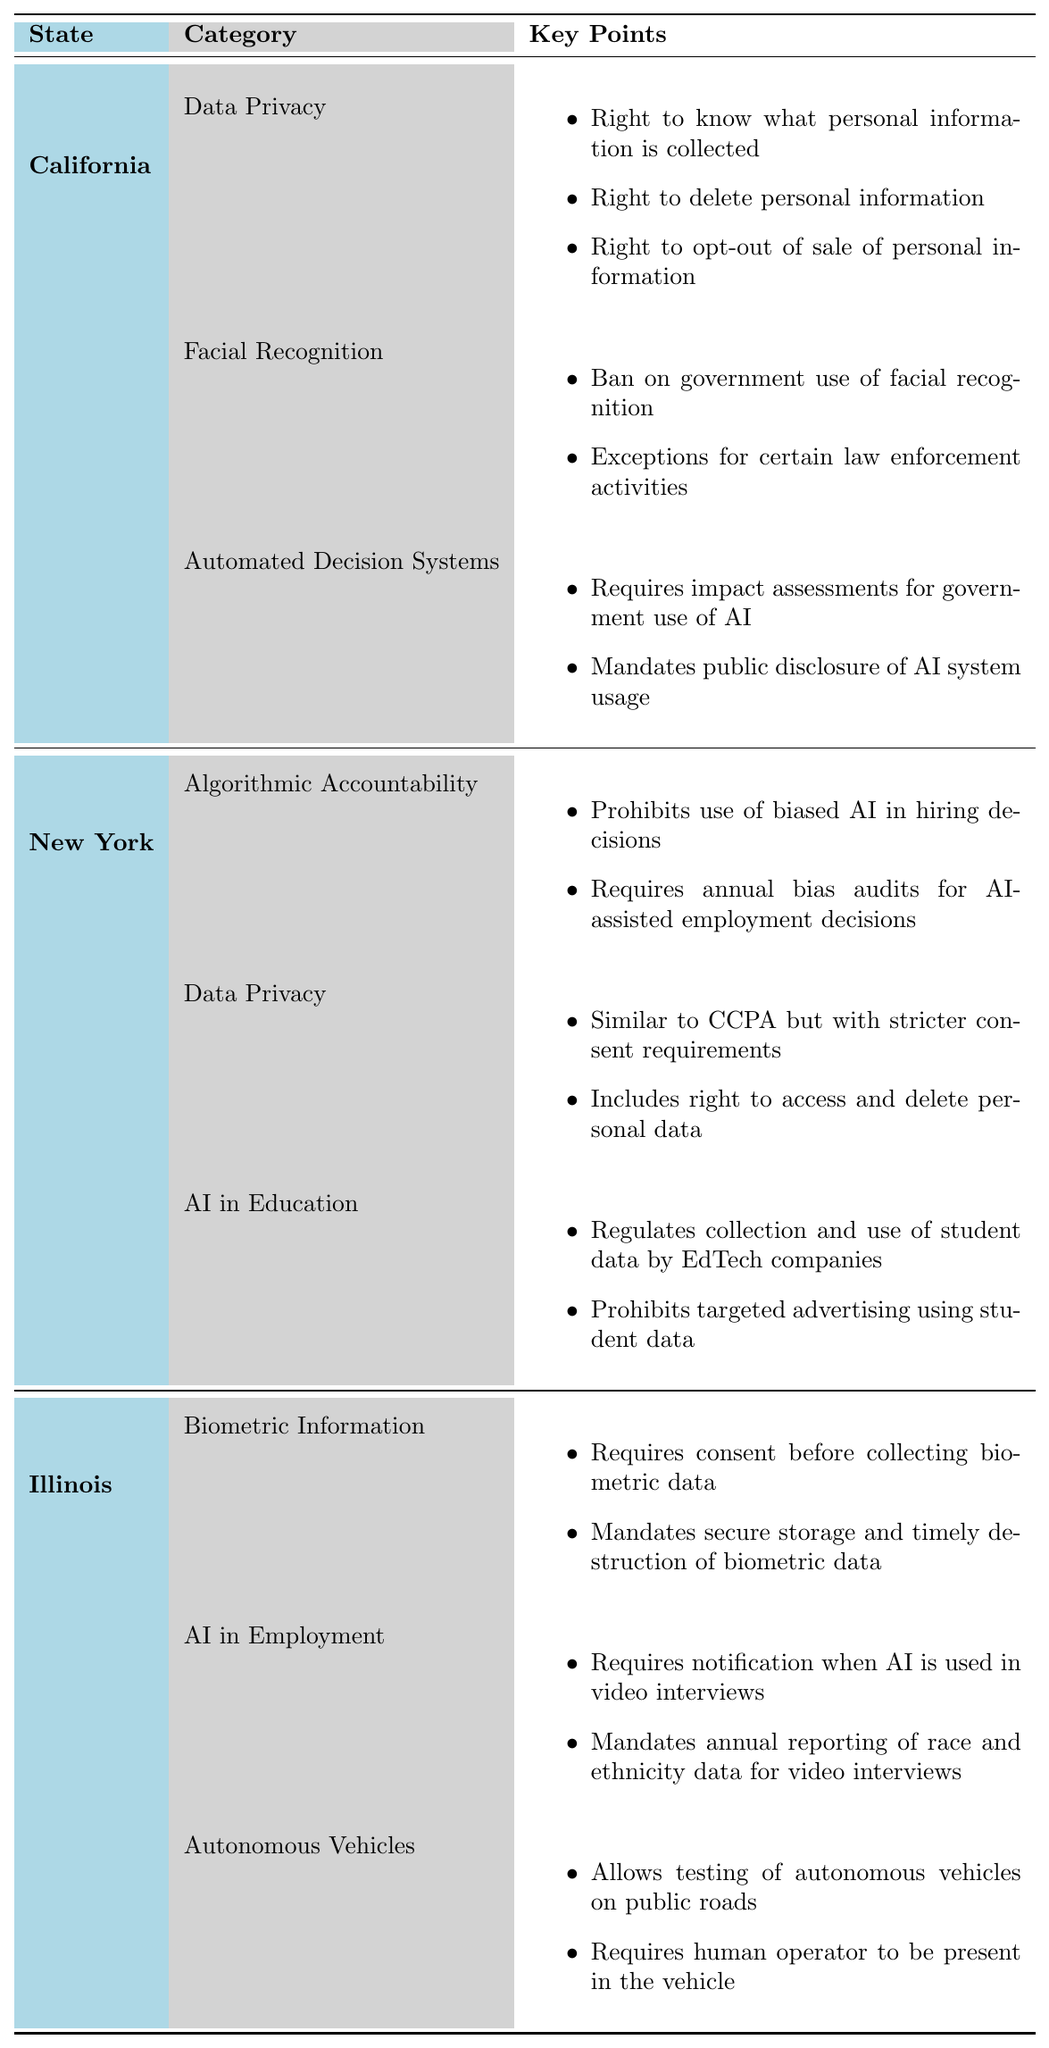What AI regulation categories are present in California? California has three categories of AI regulations: Data Privacy, Facial Recognition, and Automated Decision Systems. These categories are listed in the table under the column for California’s AI regulations.
Answer: Data Privacy, Facial Recognition, Automated Decision Systems Which state has a law regarding AI in education? New York has the Student Electronic Data Protection Act under the category of AI in Education, as indicated in the table.
Answer: New York How many laws does Illinois have regarding AI in employment? Illinois has one law under the AI in Employment category, which is the Artificial Intelligence Video Interview Act, as shown in the table.
Answer: One Does New York have any proposed laws for Data Privacy? Yes, New York has a proposed law called the New York Privacy Act, which is mentioned under the Data Privacy category in the table.
Answer: Yes Which state requires consent before collecting biometric data? Illinois requires consent before collecting biometric data, as stated in the Biometric Information category of their AI regulations in the table.
Answer: Illinois What is one key point of California's regulation on Facial Recognition? One key point is that there is a ban on government use of facial recognition, which is noted under the Facial Recognition category in California's laws.
Answer: Ban on government use of facial recognition Which state's regulations include the requirement for annual bias audits? New York’s NYC AI Bias Law requires annual bias audits for AI-assisted employment decisions, specifically mentioned in the table under Algorithmic Accountability.
Answer: New York Comparing the number of AI laws between California and Illinois, which state has more? California has three laws in total (Data Privacy, Facial Recognition, Automated Decision Systems), while Illinois has three laws (Biometric Information, AI in Employment, Autonomous Vehicles). Therefore, they have an equal number of AI laws.
Answer: They have an equal number What key point is unique to New York's AI regulations in education? One unique key point for New York's regulations in education is the prohibition of targeted advertising using student data, which is specified in the Student Electronic Data Protection Act.
Answer: Prohibits targeted advertising using student data Which state has a law that mandates public disclosure of AI system usage? California's Automated Decision Systems Accountability Act mandates public disclosure of AI system usage, as per the table details under that category.
Answer: California What is the main difference between California's CCPA and New York's proposed privacy act? The primary difference is that New York's proposed act has stricter consent requirements compared to California's CCPA, as described under the Data Privacy categories for the two states.
Answer: Stricter consent requirements in New York 